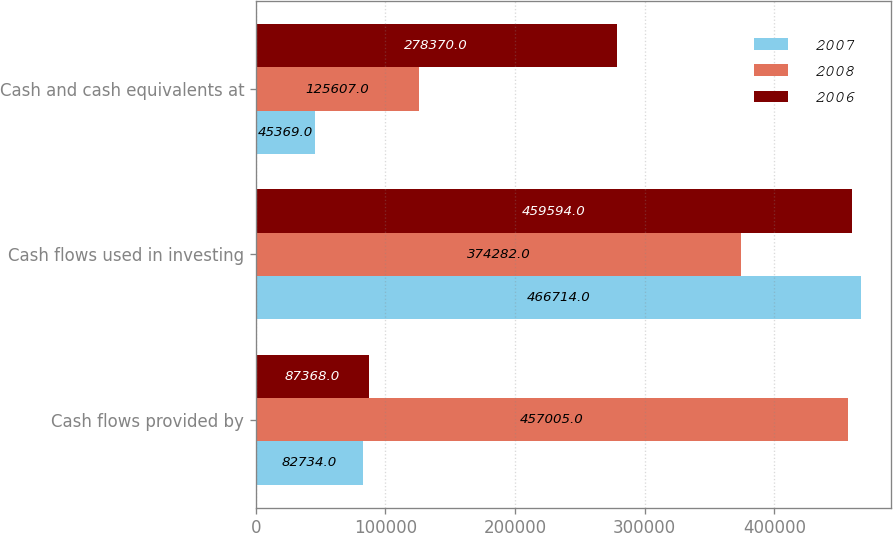Convert chart. <chart><loc_0><loc_0><loc_500><loc_500><stacked_bar_chart><ecel><fcel>Cash flows provided by<fcel>Cash flows used in investing<fcel>Cash and cash equivalents at<nl><fcel>2007<fcel>82734<fcel>466714<fcel>45369<nl><fcel>2008<fcel>457005<fcel>374282<fcel>125607<nl><fcel>2006<fcel>87368<fcel>459594<fcel>278370<nl></chart> 